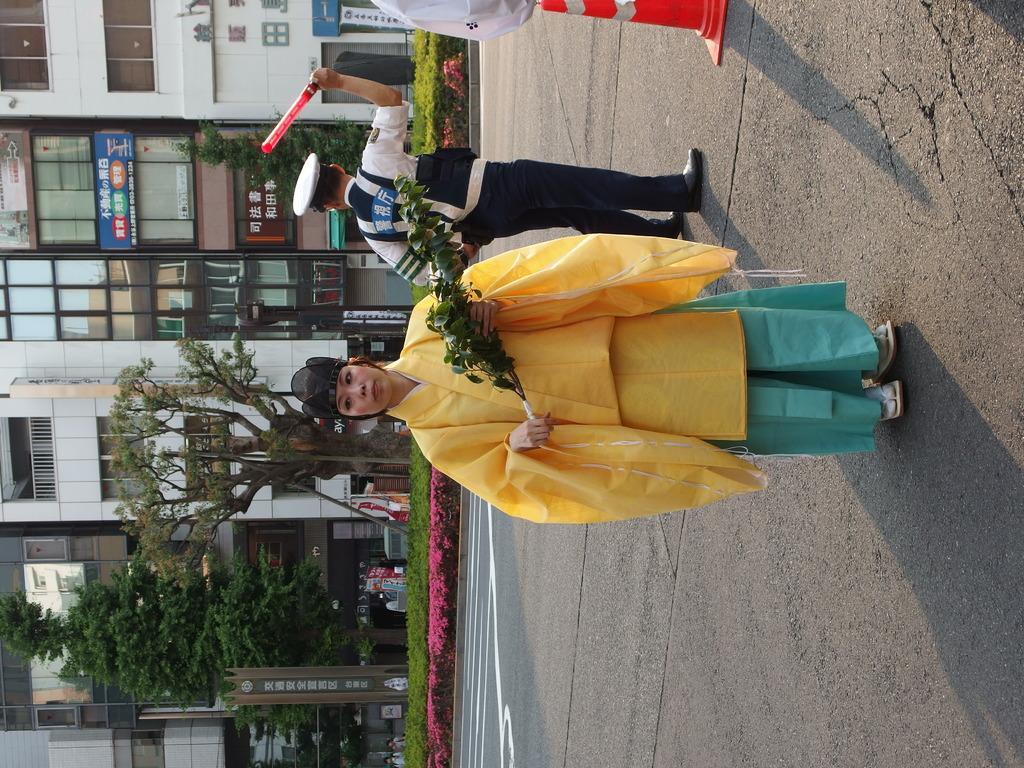Describe this image in one or two sentences. In this picture there is a woman standing and holding the plant and there is a man standing and holding the object and there is an object on the road. At the back there are buildings and trees. There are boards on the wall and there is text on the boards. There are plants and there are two people standing at the building. 